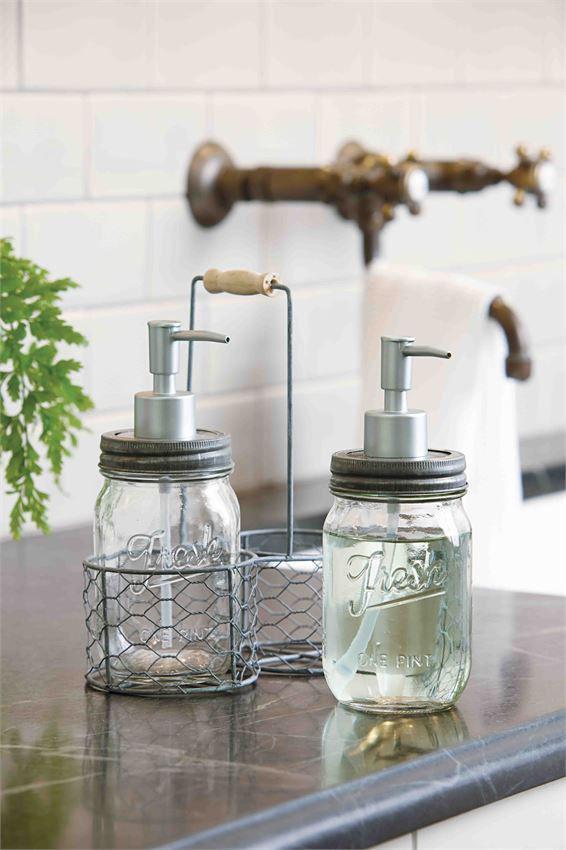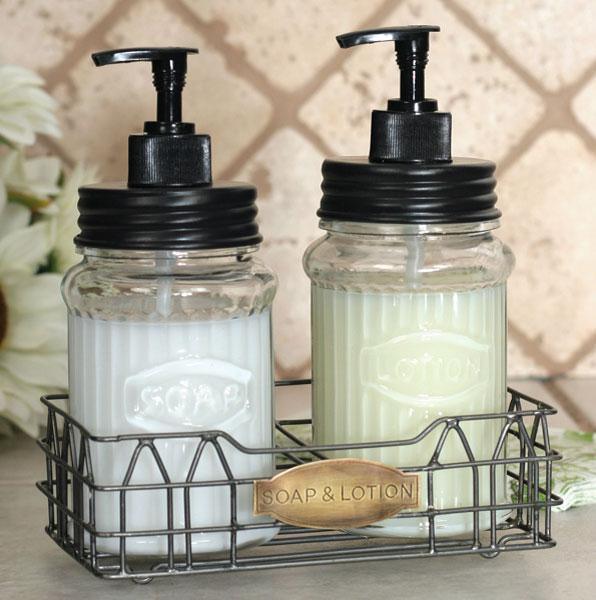The first image is the image on the left, the second image is the image on the right. Considering the images on both sides, is "Each image shows a pair of pump dispensers, and each pair of dispensers is shown with a caddy holder." valid? Answer yes or no. Yes. The first image is the image on the left, the second image is the image on the right. Analyze the images presented: Is the assertion "Two jars are sitting in a carrier in one of the images." valid? Answer yes or no. Yes. 